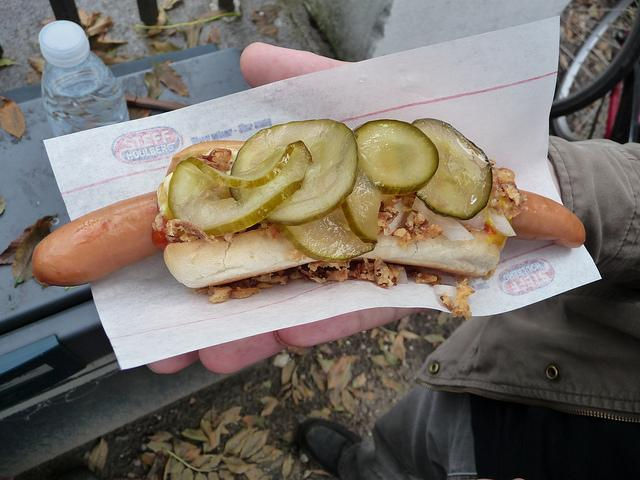What type of solution were the cucumbers soaked in? brine 